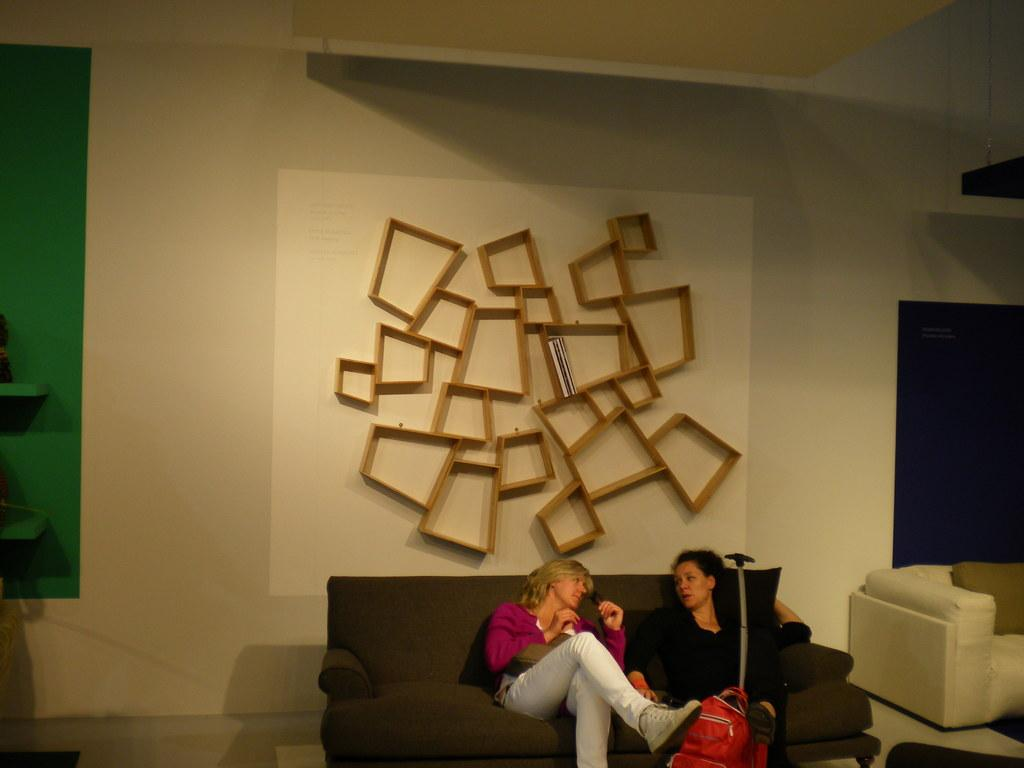How many women are seated on the sofa in the image? There are two women seated on the sofa in the image. What is the woman holding in the image? The woman is holding a trolley bag. What can be seen on the wall behind the women? There is a wooden cupboard on the wall behind the women. What type of operation is being performed on the cemetery in the image? There is no cemetery or operation present in the image; it features two women seated on a sofa and a woman holding a trolley bag. 